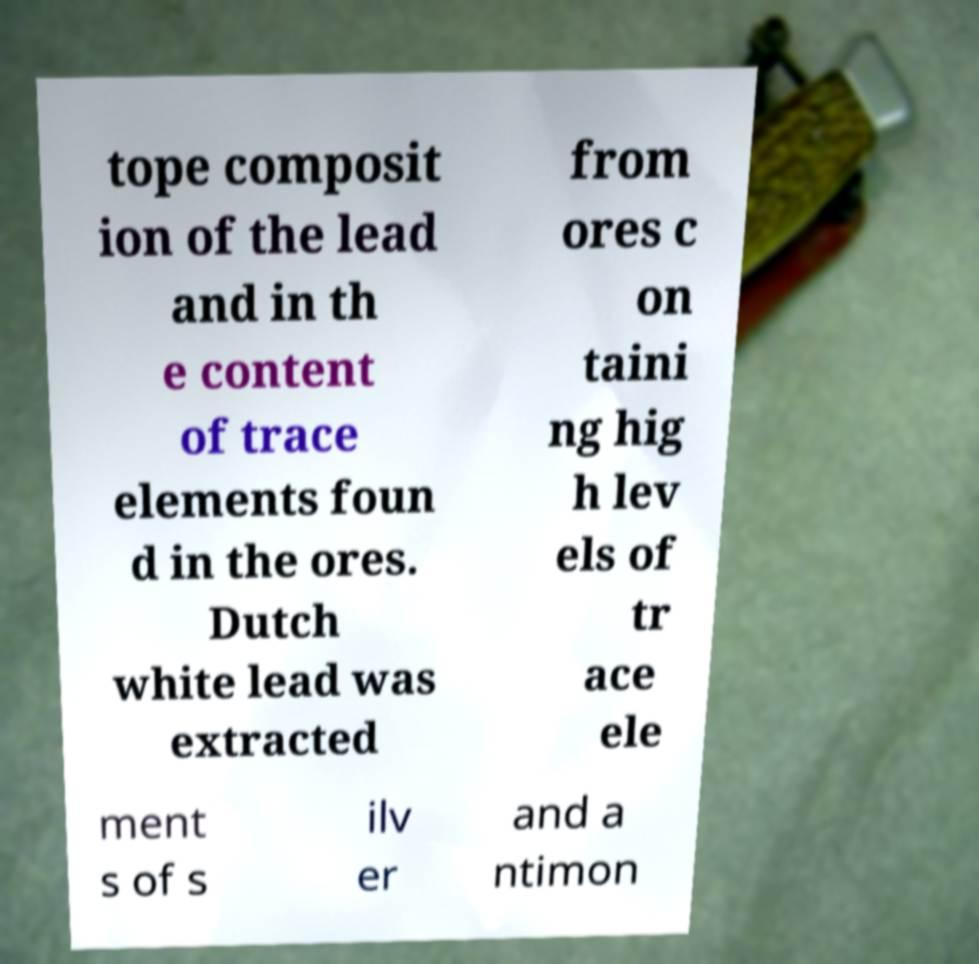Can you accurately transcribe the text from the provided image for me? tope composit ion of the lead and in th e content of trace elements foun d in the ores. Dutch white lead was extracted from ores c on taini ng hig h lev els of tr ace ele ment s of s ilv er and a ntimon 